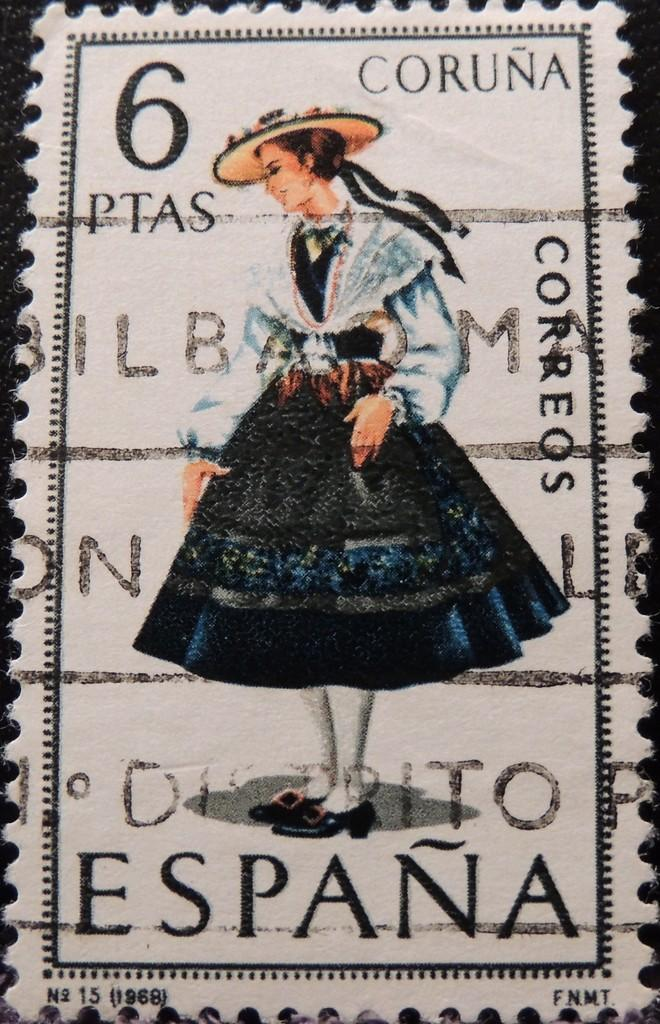What is the main object in the image? There is a card in the image. Who is present in the image? There is a woman in the image. What else can be seen in the image besides the card and the woman? There is some text in the image. How many spiders are crawling on the card in the image? There are no spiders present in the image; it only features a card, a woman, and some text. What type of bun is the woman holding in the image? There is no bun present in the image; the woman is not holding any food item. 